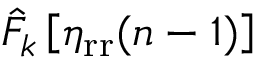Convert formula to latex. <formula><loc_0><loc_0><loc_500><loc_500>\hat { F } _ { k } \left [ \eta _ { r r } ( n - 1 ) \right ]</formula> 